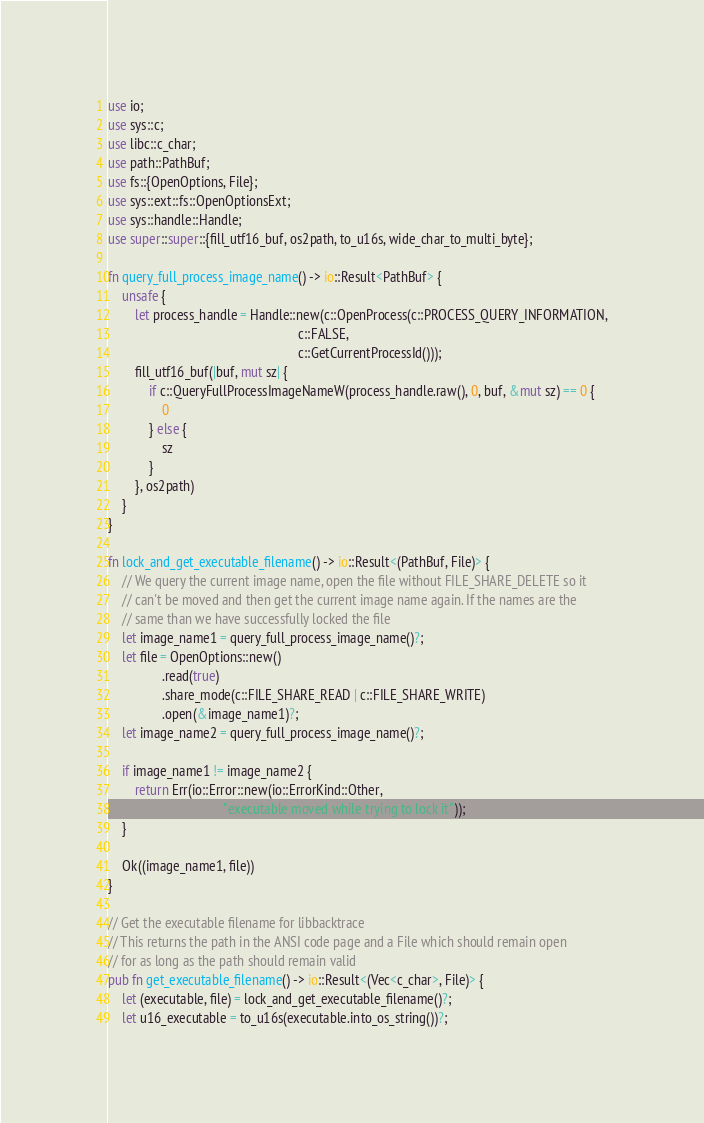Convert code to text. <code><loc_0><loc_0><loc_500><loc_500><_Rust_>use io;
use sys::c;
use libc::c_char;
use path::PathBuf;
use fs::{OpenOptions, File};
use sys::ext::fs::OpenOptionsExt;
use sys::handle::Handle;
use super::super::{fill_utf16_buf, os2path, to_u16s, wide_char_to_multi_byte};

fn query_full_process_image_name() -> io::Result<PathBuf> {
    unsafe {
        let process_handle = Handle::new(c::OpenProcess(c::PROCESS_QUERY_INFORMATION,
                                                        c::FALSE,
                                                        c::GetCurrentProcessId()));
        fill_utf16_buf(|buf, mut sz| {
            if c::QueryFullProcessImageNameW(process_handle.raw(), 0, buf, &mut sz) == 0 {
                0
            } else {
                sz
            }
        }, os2path)
    }
}

fn lock_and_get_executable_filename() -> io::Result<(PathBuf, File)> {
    // We query the current image name, open the file without FILE_SHARE_DELETE so it
    // can't be moved and then get the current image name again. If the names are the
    // same than we have successfully locked the file
    let image_name1 = query_full_process_image_name()?;
    let file = OpenOptions::new()
                .read(true)
                .share_mode(c::FILE_SHARE_READ | c::FILE_SHARE_WRITE)
                .open(&image_name1)?;
    let image_name2 = query_full_process_image_name()?;

    if image_name1 != image_name2 {
        return Err(io::Error::new(io::ErrorKind::Other,
                                  "executable moved while trying to lock it"));
    }

    Ok((image_name1, file))
}

// Get the executable filename for libbacktrace
// This returns the path in the ANSI code page and a File which should remain open
// for as long as the path should remain valid
pub fn get_executable_filename() -> io::Result<(Vec<c_char>, File)> {
    let (executable, file) = lock_and_get_executable_filename()?;
    let u16_executable = to_u16s(executable.into_os_string())?;</code> 